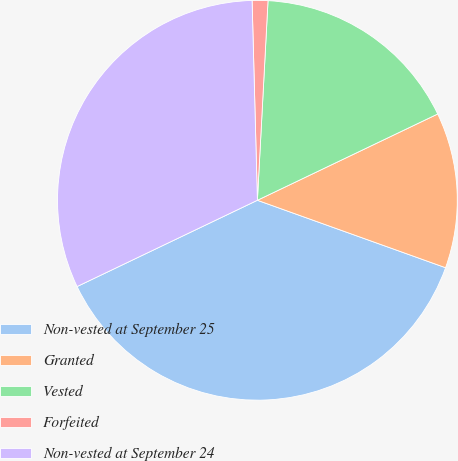<chart> <loc_0><loc_0><loc_500><loc_500><pie_chart><fcel>Non-vested at September 25<fcel>Granted<fcel>Vested<fcel>Forfeited<fcel>Non-vested at September 24<nl><fcel>37.42%<fcel>12.58%<fcel>17.05%<fcel>1.27%<fcel>31.68%<nl></chart> 